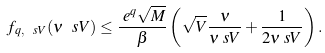<formula> <loc_0><loc_0><loc_500><loc_500>f _ { q , \ s V } ( \nu _ { \ } s V ) & \leq \frac { \ e ^ { q } \sqrt { M } } { \beta } \left ( \sqrt { V } \frac { \nu } { \nu _ { \ } s V } + \frac { 1 } { 2 \nu _ { \ } s V } \right ) .</formula> 